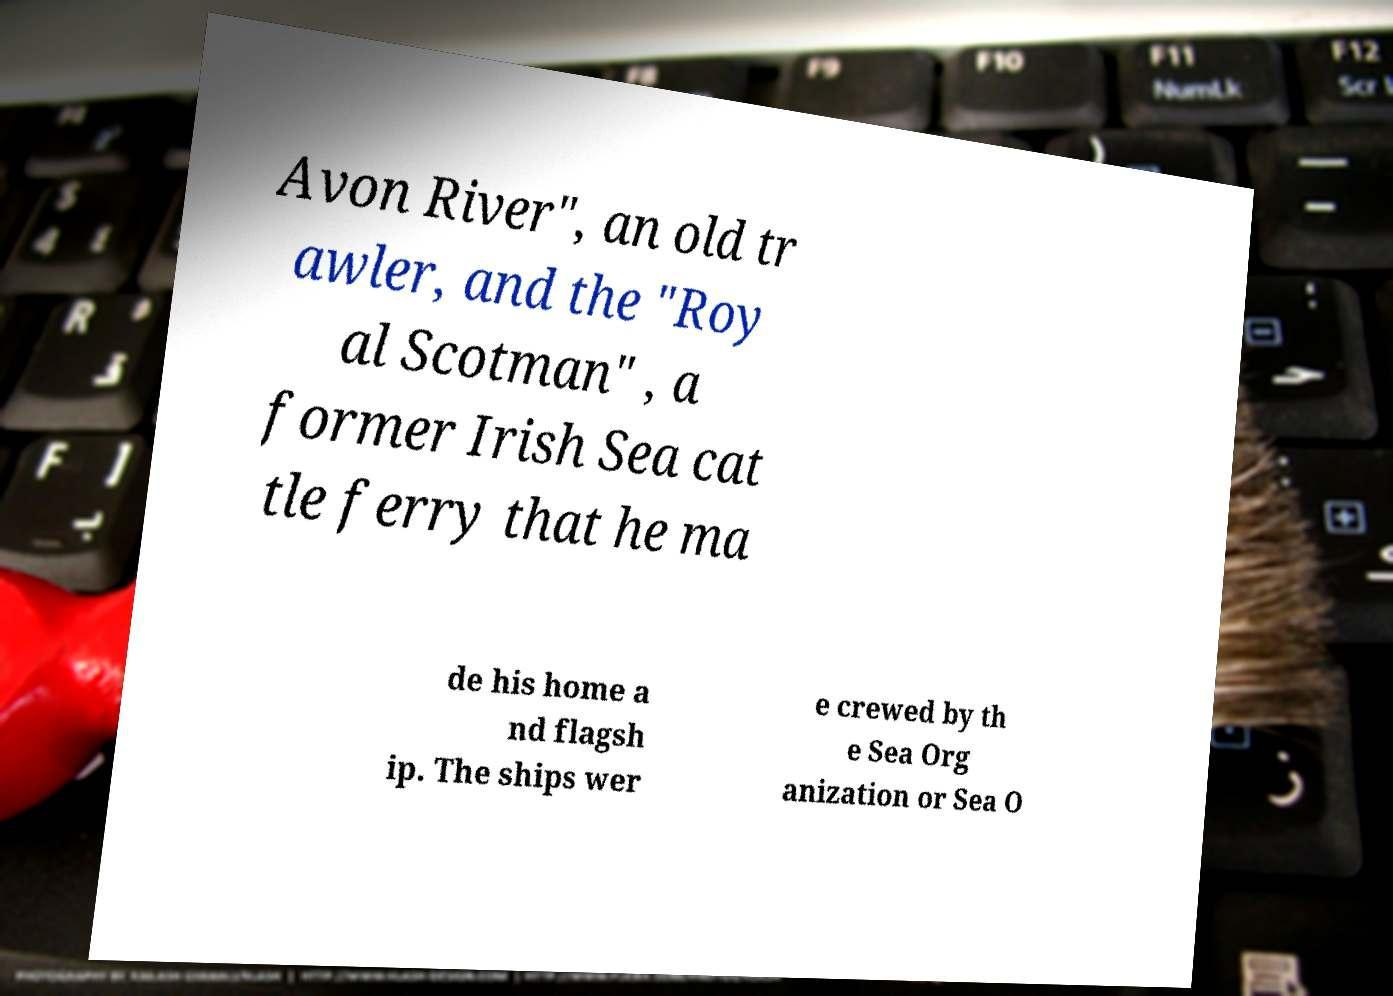Please identify and transcribe the text found in this image. Avon River", an old tr awler, and the "Roy al Scotman" , a former Irish Sea cat tle ferry that he ma de his home a nd flagsh ip. The ships wer e crewed by th e Sea Org anization or Sea O 